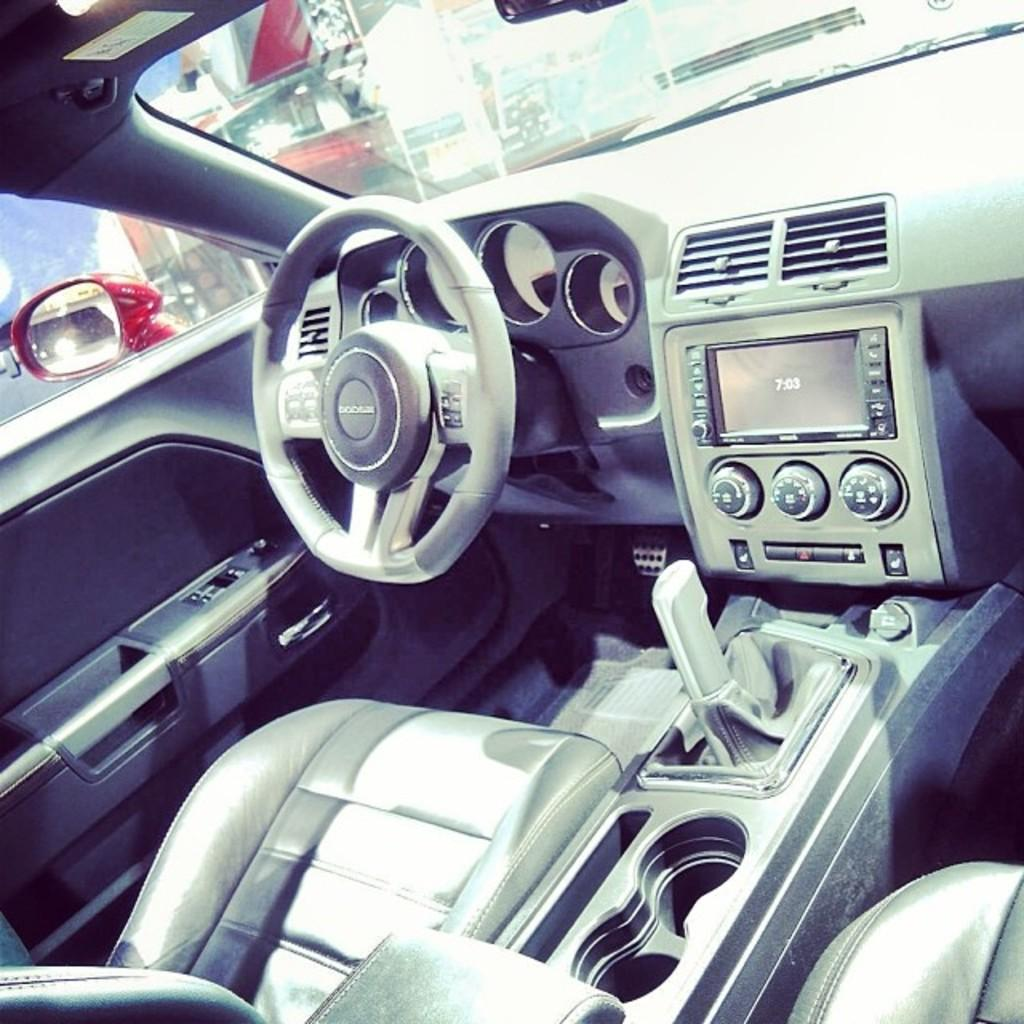What type of space is depicted in the image? The image shows the inside of a vehicle. What is used to control the direction of the vehicle? There is a steering wheel in the vehicle. How can the driver change the speed of the vehicle? There is a gear rod in the vehicle. What device is present for entertainment or information? There is a radio in the vehicle. What is provided for the driver or passengers to sit on? There is a seat in the vehicle. What material is used for the windows of the vehicle? There are glass windows in the vehicle. How can the driver see the traffic behind them? A side mirror is visible through one of the windows. What type of jam is spread on the seat in the image? There is no jam present in the image; it shows the inside of a vehicle with a seat and other components. 